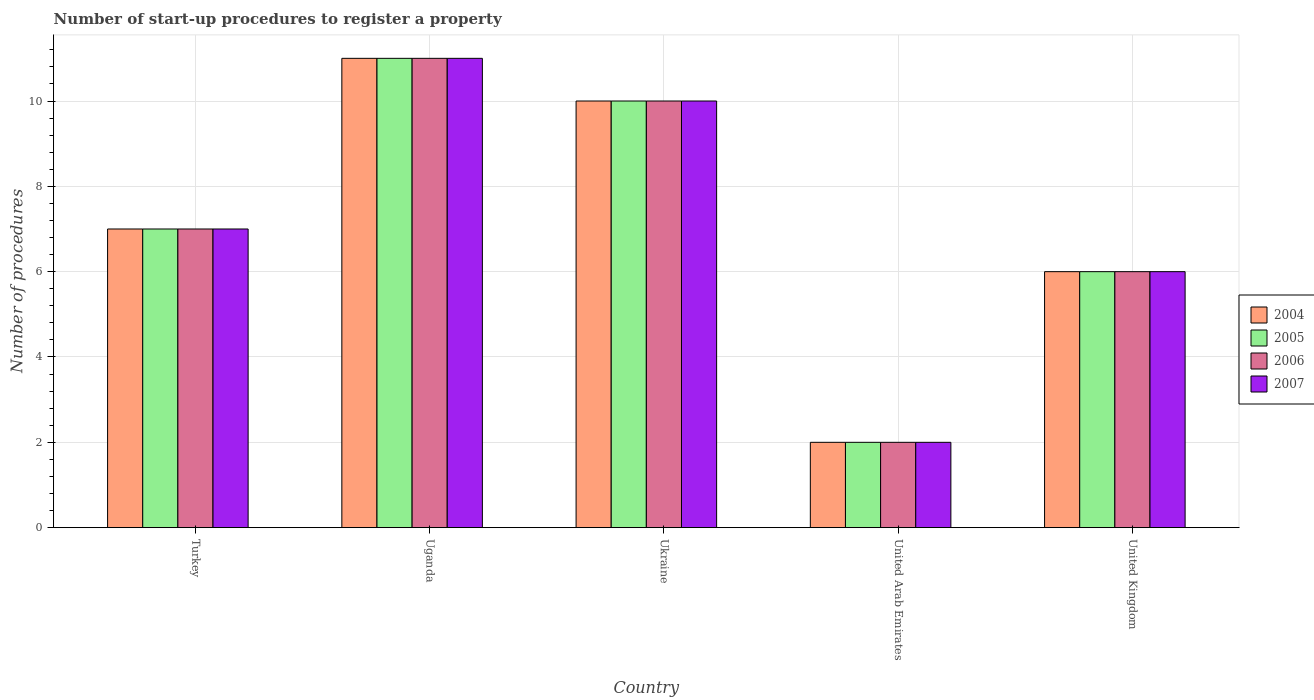How many bars are there on the 3rd tick from the right?
Your answer should be very brief. 4. What is the number of procedures required to register a property in 2005 in Ukraine?
Make the answer very short. 10. In which country was the number of procedures required to register a property in 2005 maximum?
Provide a succinct answer. Uganda. In which country was the number of procedures required to register a property in 2005 minimum?
Your answer should be compact. United Arab Emirates. What is the difference between the number of procedures required to register a property in 2004 in Uganda and that in United Arab Emirates?
Provide a succinct answer. 9. What is the difference between the number of procedures required to register a property in 2006 in United Kingdom and the number of procedures required to register a property in 2005 in Uganda?
Give a very brief answer. -5. What is the average number of procedures required to register a property in 2004 per country?
Ensure brevity in your answer.  7.2. What is the ratio of the number of procedures required to register a property in 2006 in Turkey to that in Uganda?
Keep it short and to the point. 0.64. Is the number of procedures required to register a property in 2005 in Turkey less than that in United Kingdom?
Keep it short and to the point. No. What is the difference between the highest and the second highest number of procedures required to register a property in 2004?
Offer a terse response. -1. Is it the case that in every country, the sum of the number of procedures required to register a property in 2005 and number of procedures required to register a property in 2007 is greater than the sum of number of procedures required to register a property in 2004 and number of procedures required to register a property in 2006?
Ensure brevity in your answer.  No. What does the 3rd bar from the left in United Kingdom represents?
Give a very brief answer. 2006. What does the 3rd bar from the right in United Kingdom represents?
Ensure brevity in your answer.  2005. How many bars are there?
Give a very brief answer. 20. Are all the bars in the graph horizontal?
Make the answer very short. No. How many countries are there in the graph?
Provide a short and direct response. 5. What is the difference between two consecutive major ticks on the Y-axis?
Offer a very short reply. 2. How many legend labels are there?
Make the answer very short. 4. How are the legend labels stacked?
Ensure brevity in your answer.  Vertical. What is the title of the graph?
Ensure brevity in your answer.  Number of start-up procedures to register a property. Does "2004" appear as one of the legend labels in the graph?
Make the answer very short. Yes. What is the label or title of the X-axis?
Offer a terse response. Country. What is the label or title of the Y-axis?
Your answer should be compact. Number of procedures. What is the Number of procedures of 2004 in Turkey?
Your answer should be compact. 7. What is the Number of procedures of 2006 in Turkey?
Keep it short and to the point. 7. What is the Number of procedures of 2005 in Uganda?
Your answer should be compact. 11. What is the Number of procedures in 2006 in Uganda?
Provide a short and direct response. 11. What is the Number of procedures in 2007 in Uganda?
Your answer should be very brief. 11. What is the Number of procedures of 2004 in United Arab Emirates?
Provide a succinct answer. 2. What is the Number of procedures in 2005 in United Arab Emirates?
Your answer should be compact. 2. What is the Number of procedures in 2006 in United Arab Emirates?
Keep it short and to the point. 2. What is the Number of procedures in 2007 in United Arab Emirates?
Your answer should be very brief. 2. What is the Number of procedures of 2004 in United Kingdom?
Make the answer very short. 6. What is the Number of procedures of 2006 in United Kingdom?
Make the answer very short. 6. What is the Number of procedures in 2007 in United Kingdom?
Keep it short and to the point. 6. Across all countries, what is the maximum Number of procedures of 2005?
Provide a succinct answer. 11. Across all countries, what is the maximum Number of procedures in 2006?
Ensure brevity in your answer.  11. Across all countries, what is the minimum Number of procedures of 2006?
Ensure brevity in your answer.  2. What is the difference between the Number of procedures of 2004 in Turkey and that in Uganda?
Your response must be concise. -4. What is the difference between the Number of procedures of 2007 in Turkey and that in Uganda?
Your answer should be compact. -4. What is the difference between the Number of procedures in 2005 in Turkey and that in Ukraine?
Ensure brevity in your answer.  -3. What is the difference between the Number of procedures in 2006 in Turkey and that in Ukraine?
Your response must be concise. -3. What is the difference between the Number of procedures in 2007 in Turkey and that in Ukraine?
Keep it short and to the point. -3. What is the difference between the Number of procedures in 2004 in Turkey and that in United Arab Emirates?
Ensure brevity in your answer.  5. What is the difference between the Number of procedures of 2005 in Turkey and that in United Arab Emirates?
Your answer should be compact. 5. What is the difference between the Number of procedures of 2007 in Turkey and that in United Arab Emirates?
Ensure brevity in your answer.  5. What is the difference between the Number of procedures of 2005 in Turkey and that in United Kingdom?
Make the answer very short. 1. What is the difference between the Number of procedures in 2006 in Turkey and that in United Kingdom?
Make the answer very short. 1. What is the difference between the Number of procedures in 2007 in Turkey and that in United Kingdom?
Provide a succinct answer. 1. What is the difference between the Number of procedures of 2004 in Uganda and that in Ukraine?
Ensure brevity in your answer.  1. What is the difference between the Number of procedures of 2005 in Uganda and that in Ukraine?
Your answer should be very brief. 1. What is the difference between the Number of procedures of 2006 in Uganda and that in Ukraine?
Provide a succinct answer. 1. What is the difference between the Number of procedures of 2004 in Uganda and that in United Arab Emirates?
Give a very brief answer. 9. What is the difference between the Number of procedures of 2005 in Uganda and that in United Arab Emirates?
Give a very brief answer. 9. What is the difference between the Number of procedures in 2007 in Uganda and that in United Kingdom?
Your answer should be very brief. 5. What is the difference between the Number of procedures in 2004 in Ukraine and that in United Arab Emirates?
Provide a short and direct response. 8. What is the difference between the Number of procedures of 2005 in Ukraine and that in United Arab Emirates?
Keep it short and to the point. 8. What is the difference between the Number of procedures in 2006 in Ukraine and that in United Arab Emirates?
Offer a terse response. 8. What is the difference between the Number of procedures of 2007 in Ukraine and that in United Arab Emirates?
Your answer should be very brief. 8. What is the difference between the Number of procedures of 2004 in United Arab Emirates and that in United Kingdom?
Your response must be concise. -4. What is the difference between the Number of procedures in 2006 in United Arab Emirates and that in United Kingdom?
Provide a short and direct response. -4. What is the difference between the Number of procedures of 2004 in Turkey and the Number of procedures of 2005 in Uganda?
Offer a very short reply. -4. What is the difference between the Number of procedures of 2004 in Turkey and the Number of procedures of 2006 in Uganda?
Make the answer very short. -4. What is the difference between the Number of procedures of 2005 in Turkey and the Number of procedures of 2007 in Uganda?
Offer a terse response. -4. What is the difference between the Number of procedures of 2006 in Turkey and the Number of procedures of 2007 in Uganda?
Ensure brevity in your answer.  -4. What is the difference between the Number of procedures in 2004 in Turkey and the Number of procedures in 2005 in Ukraine?
Offer a terse response. -3. What is the difference between the Number of procedures in 2005 in Turkey and the Number of procedures in 2006 in Ukraine?
Ensure brevity in your answer.  -3. What is the difference between the Number of procedures in 2006 in Turkey and the Number of procedures in 2007 in Ukraine?
Keep it short and to the point. -3. What is the difference between the Number of procedures in 2004 in Turkey and the Number of procedures in 2005 in United Arab Emirates?
Keep it short and to the point. 5. What is the difference between the Number of procedures of 2004 in Turkey and the Number of procedures of 2006 in United Arab Emirates?
Keep it short and to the point. 5. What is the difference between the Number of procedures of 2005 in Turkey and the Number of procedures of 2006 in United Arab Emirates?
Provide a succinct answer. 5. What is the difference between the Number of procedures in 2005 in Turkey and the Number of procedures in 2007 in United Arab Emirates?
Your response must be concise. 5. What is the difference between the Number of procedures of 2004 in Turkey and the Number of procedures of 2005 in United Kingdom?
Your answer should be compact. 1. What is the difference between the Number of procedures in 2005 in Turkey and the Number of procedures in 2006 in United Kingdom?
Your answer should be very brief. 1. What is the difference between the Number of procedures of 2005 in Turkey and the Number of procedures of 2007 in United Kingdom?
Provide a short and direct response. 1. What is the difference between the Number of procedures in 2006 in Turkey and the Number of procedures in 2007 in United Kingdom?
Your response must be concise. 1. What is the difference between the Number of procedures of 2004 in Uganda and the Number of procedures of 2005 in Ukraine?
Your answer should be compact. 1. What is the difference between the Number of procedures in 2004 in Uganda and the Number of procedures in 2006 in Ukraine?
Make the answer very short. 1. What is the difference between the Number of procedures of 2005 in Uganda and the Number of procedures of 2006 in Ukraine?
Give a very brief answer. 1. What is the difference between the Number of procedures in 2005 in Uganda and the Number of procedures in 2007 in Ukraine?
Provide a short and direct response. 1. What is the difference between the Number of procedures of 2006 in Uganda and the Number of procedures of 2007 in Ukraine?
Provide a short and direct response. 1. What is the difference between the Number of procedures in 2004 in Uganda and the Number of procedures in 2005 in United Arab Emirates?
Ensure brevity in your answer.  9. What is the difference between the Number of procedures of 2004 in Uganda and the Number of procedures of 2006 in United Arab Emirates?
Offer a terse response. 9. What is the difference between the Number of procedures of 2004 in Uganda and the Number of procedures of 2007 in United Arab Emirates?
Your response must be concise. 9. What is the difference between the Number of procedures of 2006 in Uganda and the Number of procedures of 2007 in United Arab Emirates?
Offer a terse response. 9. What is the difference between the Number of procedures of 2004 in Uganda and the Number of procedures of 2005 in United Kingdom?
Your answer should be very brief. 5. What is the difference between the Number of procedures of 2004 in Uganda and the Number of procedures of 2007 in United Kingdom?
Your answer should be compact. 5. What is the difference between the Number of procedures in 2005 in Uganda and the Number of procedures in 2006 in United Kingdom?
Offer a terse response. 5. What is the difference between the Number of procedures of 2004 in Ukraine and the Number of procedures of 2005 in United Arab Emirates?
Your response must be concise. 8. What is the difference between the Number of procedures of 2004 in Ukraine and the Number of procedures of 2006 in United Arab Emirates?
Your response must be concise. 8. What is the difference between the Number of procedures in 2004 in Ukraine and the Number of procedures in 2007 in United Arab Emirates?
Give a very brief answer. 8. What is the difference between the Number of procedures in 2005 in Ukraine and the Number of procedures in 2006 in United Arab Emirates?
Keep it short and to the point. 8. What is the difference between the Number of procedures in 2005 in Ukraine and the Number of procedures in 2007 in United Arab Emirates?
Ensure brevity in your answer.  8. What is the difference between the Number of procedures of 2006 in Ukraine and the Number of procedures of 2007 in United Arab Emirates?
Ensure brevity in your answer.  8. What is the difference between the Number of procedures in 2004 in Ukraine and the Number of procedures in 2007 in United Kingdom?
Provide a short and direct response. 4. What is the difference between the Number of procedures in 2005 in Ukraine and the Number of procedures in 2007 in United Kingdom?
Provide a short and direct response. 4. What is the difference between the Number of procedures in 2006 in Ukraine and the Number of procedures in 2007 in United Kingdom?
Provide a short and direct response. 4. What is the difference between the Number of procedures in 2004 in United Arab Emirates and the Number of procedures in 2005 in United Kingdom?
Make the answer very short. -4. What is the difference between the Number of procedures of 2004 in United Arab Emirates and the Number of procedures of 2006 in United Kingdom?
Provide a short and direct response. -4. What is the difference between the Number of procedures in 2005 in United Arab Emirates and the Number of procedures in 2006 in United Kingdom?
Provide a succinct answer. -4. What is the average Number of procedures of 2006 per country?
Offer a terse response. 7.2. What is the average Number of procedures of 2007 per country?
Provide a short and direct response. 7.2. What is the difference between the Number of procedures of 2004 and Number of procedures of 2005 in Turkey?
Provide a succinct answer. 0. What is the difference between the Number of procedures of 2004 and Number of procedures of 2007 in Turkey?
Your answer should be compact. 0. What is the difference between the Number of procedures in 2005 and Number of procedures in 2006 in Turkey?
Your response must be concise. 0. What is the difference between the Number of procedures of 2006 and Number of procedures of 2007 in Turkey?
Your response must be concise. 0. What is the difference between the Number of procedures in 2004 and Number of procedures in 2005 in Uganda?
Provide a short and direct response. 0. What is the difference between the Number of procedures in 2004 and Number of procedures in 2006 in Uganda?
Make the answer very short. 0. What is the difference between the Number of procedures of 2004 and Number of procedures of 2007 in Uganda?
Offer a very short reply. 0. What is the difference between the Number of procedures of 2005 and Number of procedures of 2006 in Uganda?
Your answer should be compact. 0. What is the difference between the Number of procedures of 2005 and Number of procedures of 2007 in Uganda?
Offer a very short reply. 0. What is the difference between the Number of procedures in 2004 and Number of procedures in 2005 in Ukraine?
Ensure brevity in your answer.  0. What is the difference between the Number of procedures in 2004 and Number of procedures in 2006 in Ukraine?
Give a very brief answer. 0. What is the difference between the Number of procedures of 2004 and Number of procedures of 2007 in Ukraine?
Make the answer very short. 0. What is the difference between the Number of procedures in 2006 and Number of procedures in 2007 in Ukraine?
Make the answer very short. 0. What is the difference between the Number of procedures in 2004 and Number of procedures in 2005 in United Arab Emirates?
Your response must be concise. 0. What is the difference between the Number of procedures in 2005 and Number of procedures in 2006 in United Arab Emirates?
Offer a very short reply. 0. What is the difference between the Number of procedures of 2006 and Number of procedures of 2007 in United Arab Emirates?
Keep it short and to the point. 0. What is the difference between the Number of procedures in 2004 and Number of procedures in 2007 in United Kingdom?
Keep it short and to the point. 0. What is the ratio of the Number of procedures in 2004 in Turkey to that in Uganda?
Your answer should be compact. 0.64. What is the ratio of the Number of procedures in 2005 in Turkey to that in Uganda?
Provide a short and direct response. 0.64. What is the ratio of the Number of procedures of 2006 in Turkey to that in Uganda?
Your answer should be very brief. 0.64. What is the ratio of the Number of procedures in 2007 in Turkey to that in Uganda?
Make the answer very short. 0.64. What is the ratio of the Number of procedures in 2005 in Turkey to that in Ukraine?
Keep it short and to the point. 0.7. What is the ratio of the Number of procedures in 2004 in Turkey to that in United Arab Emirates?
Offer a very short reply. 3.5. What is the ratio of the Number of procedures of 2005 in Turkey to that in United Arab Emirates?
Make the answer very short. 3.5. What is the ratio of the Number of procedures in 2006 in Turkey to that in United Arab Emirates?
Offer a terse response. 3.5. What is the ratio of the Number of procedures of 2004 in Turkey to that in United Kingdom?
Offer a terse response. 1.17. What is the ratio of the Number of procedures in 2006 in Turkey to that in United Kingdom?
Your answer should be compact. 1.17. What is the ratio of the Number of procedures of 2007 in Turkey to that in United Kingdom?
Provide a succinct answer. 1.17. What is the ratio of the Number of procedures of 2004 in Uganda to that in Ukraine?
Offer a terse response. 1.1. What is the ratio of the Number of procedures of 2006 in Uganda to that in Ukraine?
Provide a short and direct response. 1.1. What is the ratio of the Number of procedures in 2007 in Uganda to that in Ukraine?
Your answer should be very brief. 1.1. What is the ratio of the Number of procedures of 2006 in Uganda to that in United Arab Emirates?
Your response must be concise. 5.5. What is the ratio of the Number of procedures in 2004 in Uganda to that in United Kingdom?
Offer a very short reply. 1.83. What is the ratio of the Number of procedures in 2005 in Uganda to that in United Kingdom?
Keep it short and to the point. 1.83. What is the ratio of the Number of procedures of 2006 in Uganda to that in United Kingdom?
Your answer should be very brief. 1.83. What is the ratio of the Number of procedures in 2007 in Uganda to that in United Kingdom?
Provide a succinct answer. 1.83. What is the ratio of the Number of procedures in 2004 in Ukraine to that in United Arab Emirates?
Offer a very short reply. 5. What is the ratio of the Number of procedures of 2005 in Ukraine to that in United Arab Emirates?
Ensure brevity in your answer.  5. What is the ratio of the Number of procedures in 2006 in Ukraine to that in United Arab Emirates?
Keep it short and to the point. 5. What is the ratio of the Number of procedures in 2004 in Ukraine to that in United Kingdom?
Your response must be concise. 1.67. What is the ratio of the Number of procedures in 2006 in Ukraine to that in United Kingdom?
Your answer should be very brief. 1.67. What is the ratio of the Number of procedures in 2004 in United Arab Emirates to that in United Kingdom?
Your answer should be compact. 0.33. What is the difference between the highest and the second highest Number of procedures in 2004?
Provide a short and direct response. 1. What is the difference between the highest and the second highest Number of procedures of 2006?
Ensure brevity in your answer.  1. What is the difference between the highest and the lowest Number of procedures in 2004?
Provide a succinct answer. 9. What is the difference between the highest and the lowest Number of procedures in 2005?
Keep it short and to the point. 9. What is the difference between the highest and the lowest Number of procedures of 2006?
Ensure brevity in your answer.  9. 